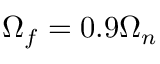Convert formula to latex. <formula><loc_0><loc_0><loc_500><loc_500>\Omega _ { f } = 0 . 9 \Omega _ { n }</formula> 